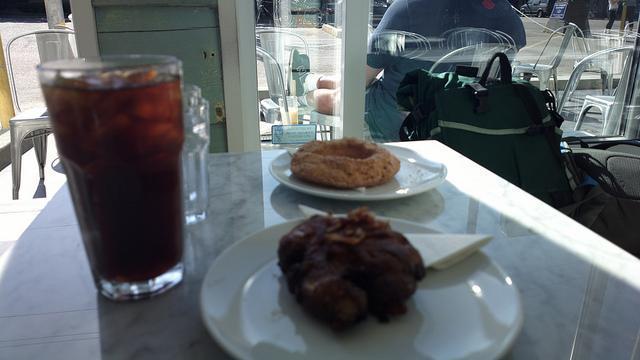How many dining tables are there?
Give a very brief answer. 3. How many cups are in the picture?
Give a very brief answer. 2. How many chairs can be seen?
Give a very brief answer. 4. 